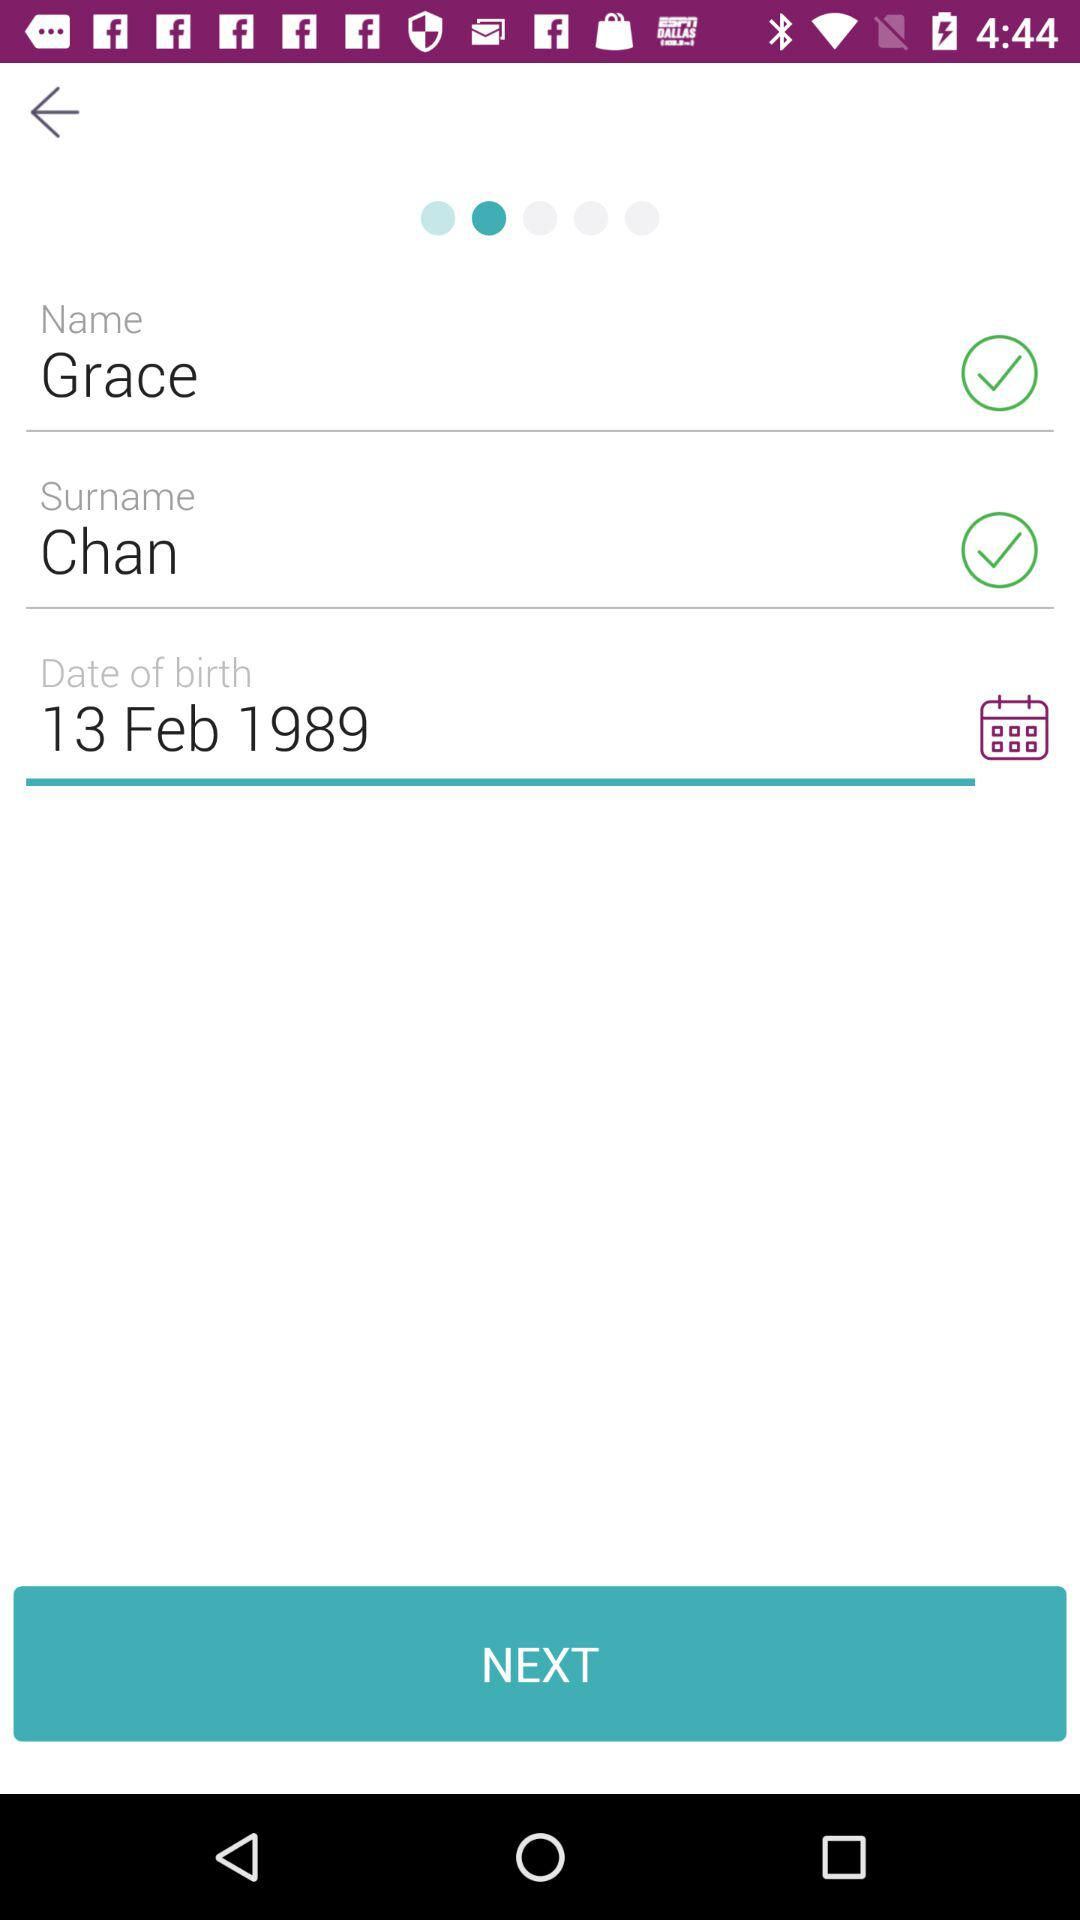What is the date of birth of the user? The date of birth of the user is February 13, 1989. 